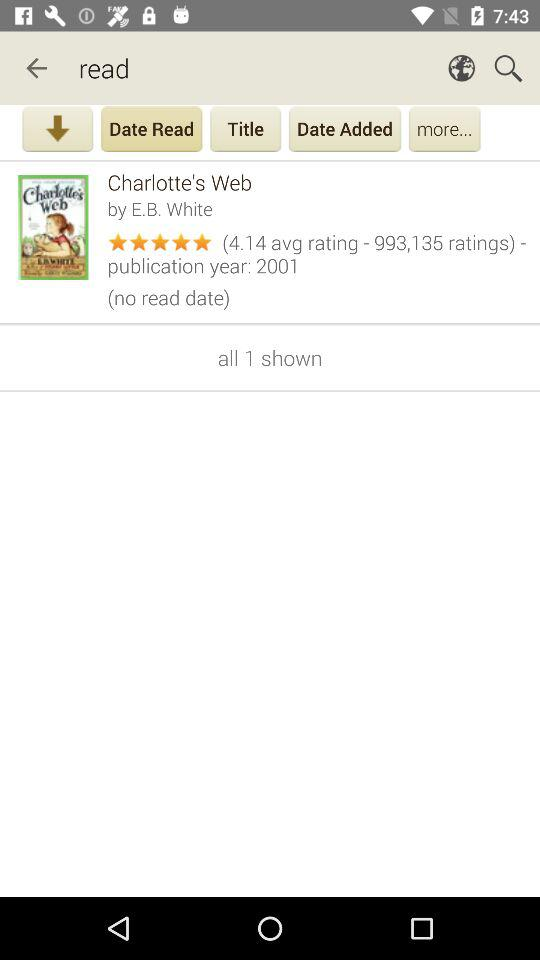What is the publication year of "Charlotte's Web"? The publication year is 2001. 